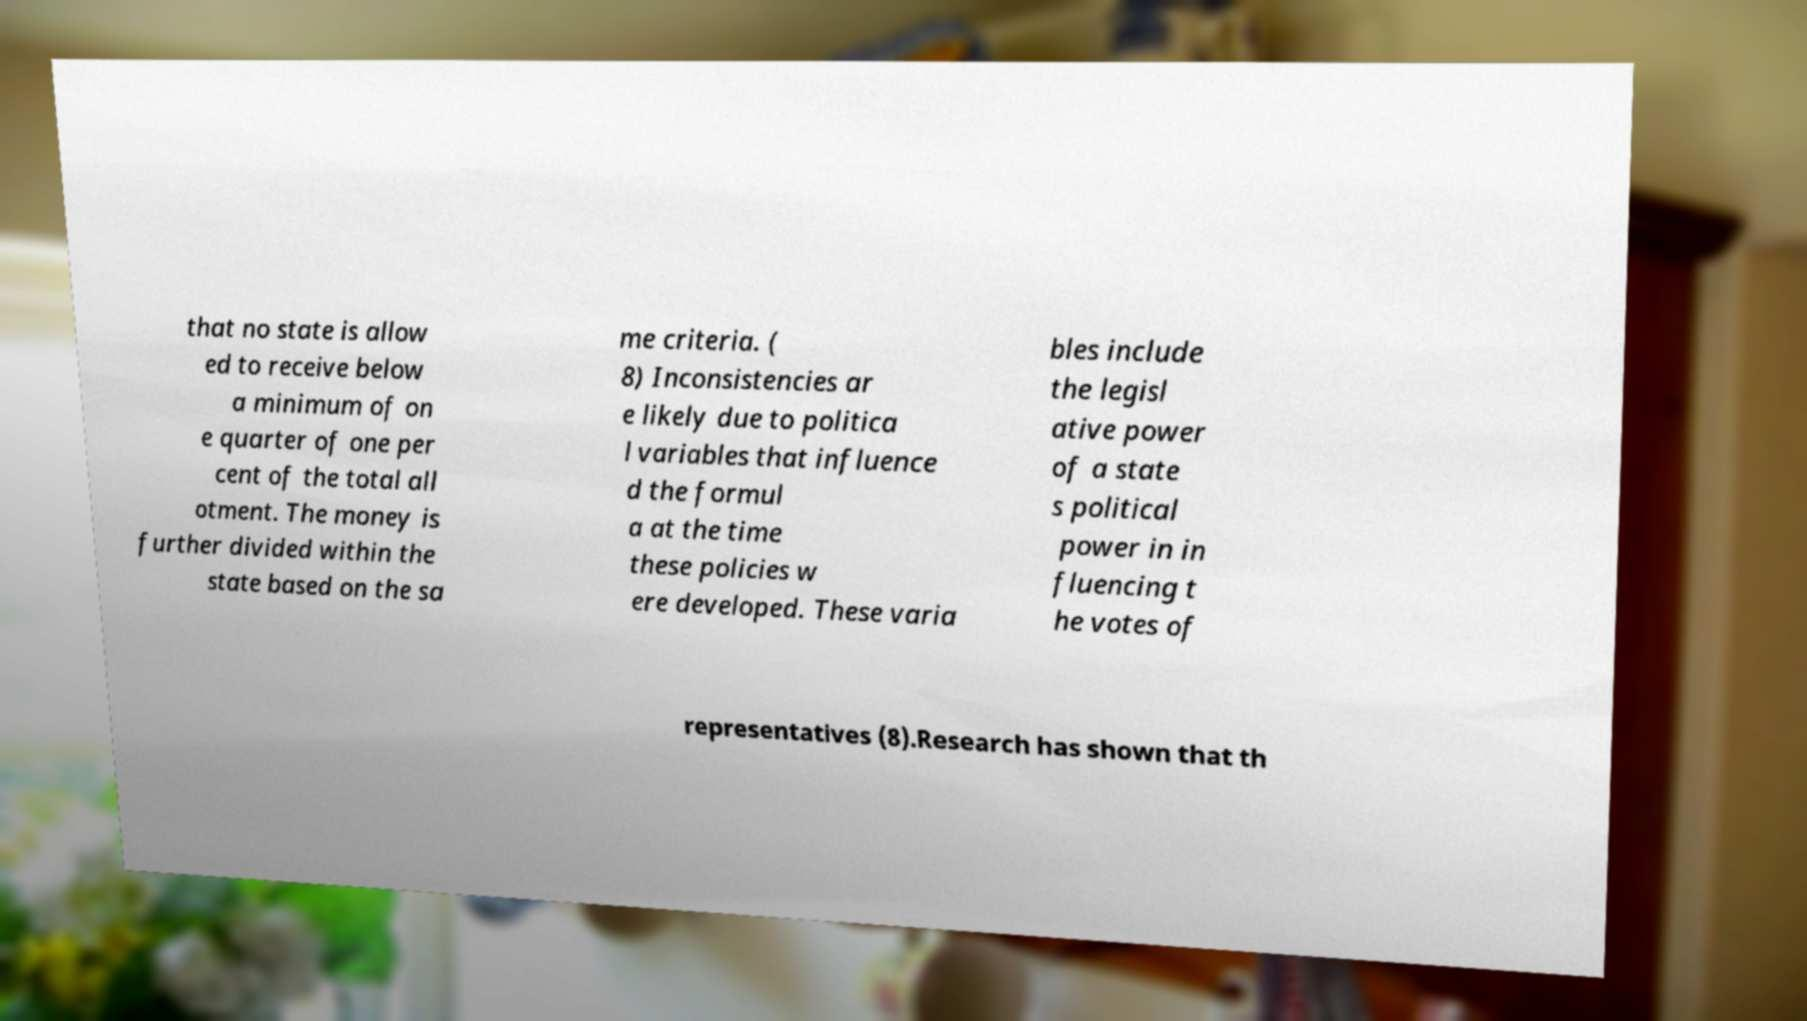There's text embedded in this image that I need extracted. Can you transcribe it verbatim? that no state is allow ed to receive below a minimum of on e quarter of one per cent of the total all otment. The money is further divided within the state based on the sa me criteria. ( 8) Inconsistencies ar e likely due to politica l variables that influence d the formul a at the time these policies w ere developed. These varia bles include the legisl ative power of a state s political power in in fluencing t he votes of representatives (8).Research has shown that th 